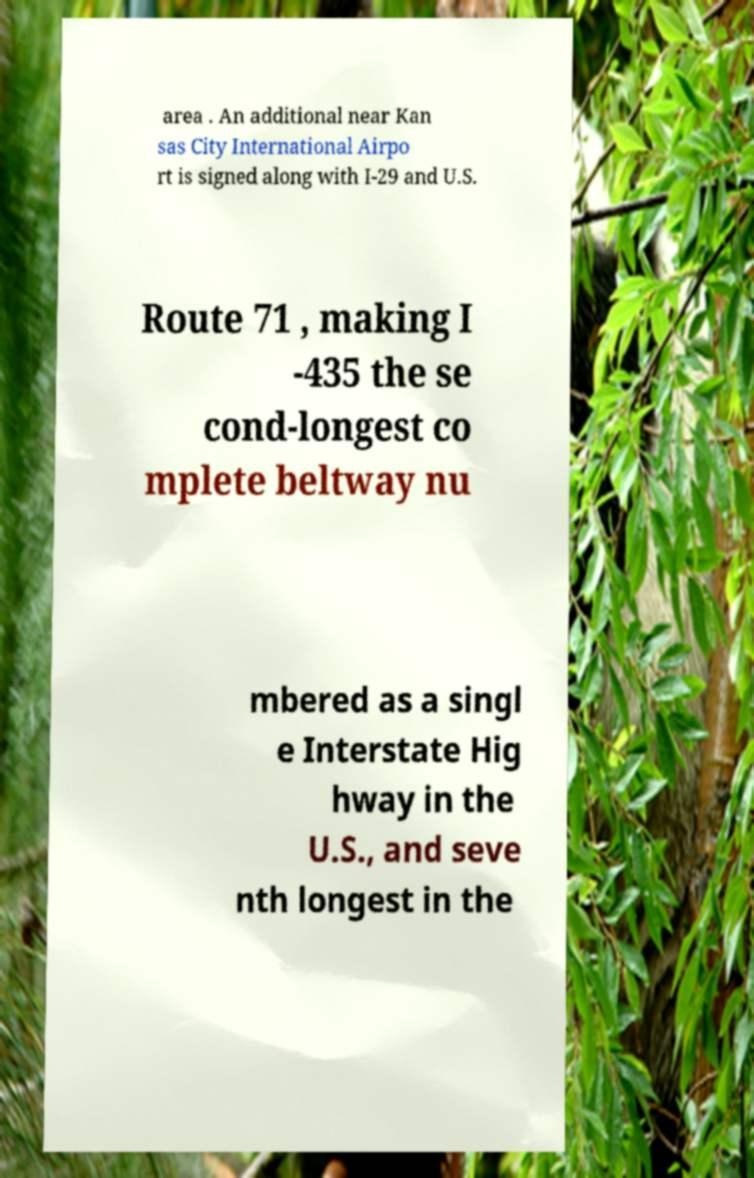For documentation purposes, I need the text within this image transcribed. Could you provide that? area . An additional near Kan sas City International Airpo rt is signed along with I-29 and U.S. Route 71 , making I -435 the se cond-longest co mplete beltway nu mbered as a singl e Interstate Hig hway in the U.S., and seve nth longest in the 